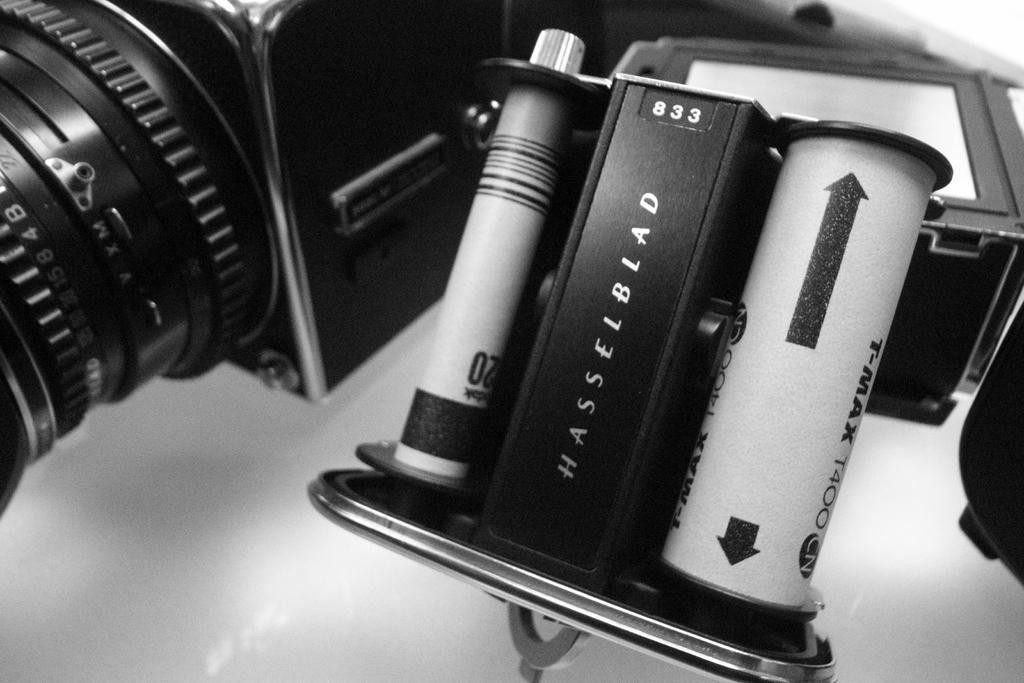What type of camera is in the image? There is a black color camera in the image. Is there any text or writing on the camera? Yes, there is something written on the camera. What color is the background of the image? The background of the image is white. How many balls are visible in the image? There are no balls present in the image. Is there a cow in the image? There is no cow present in the image. 